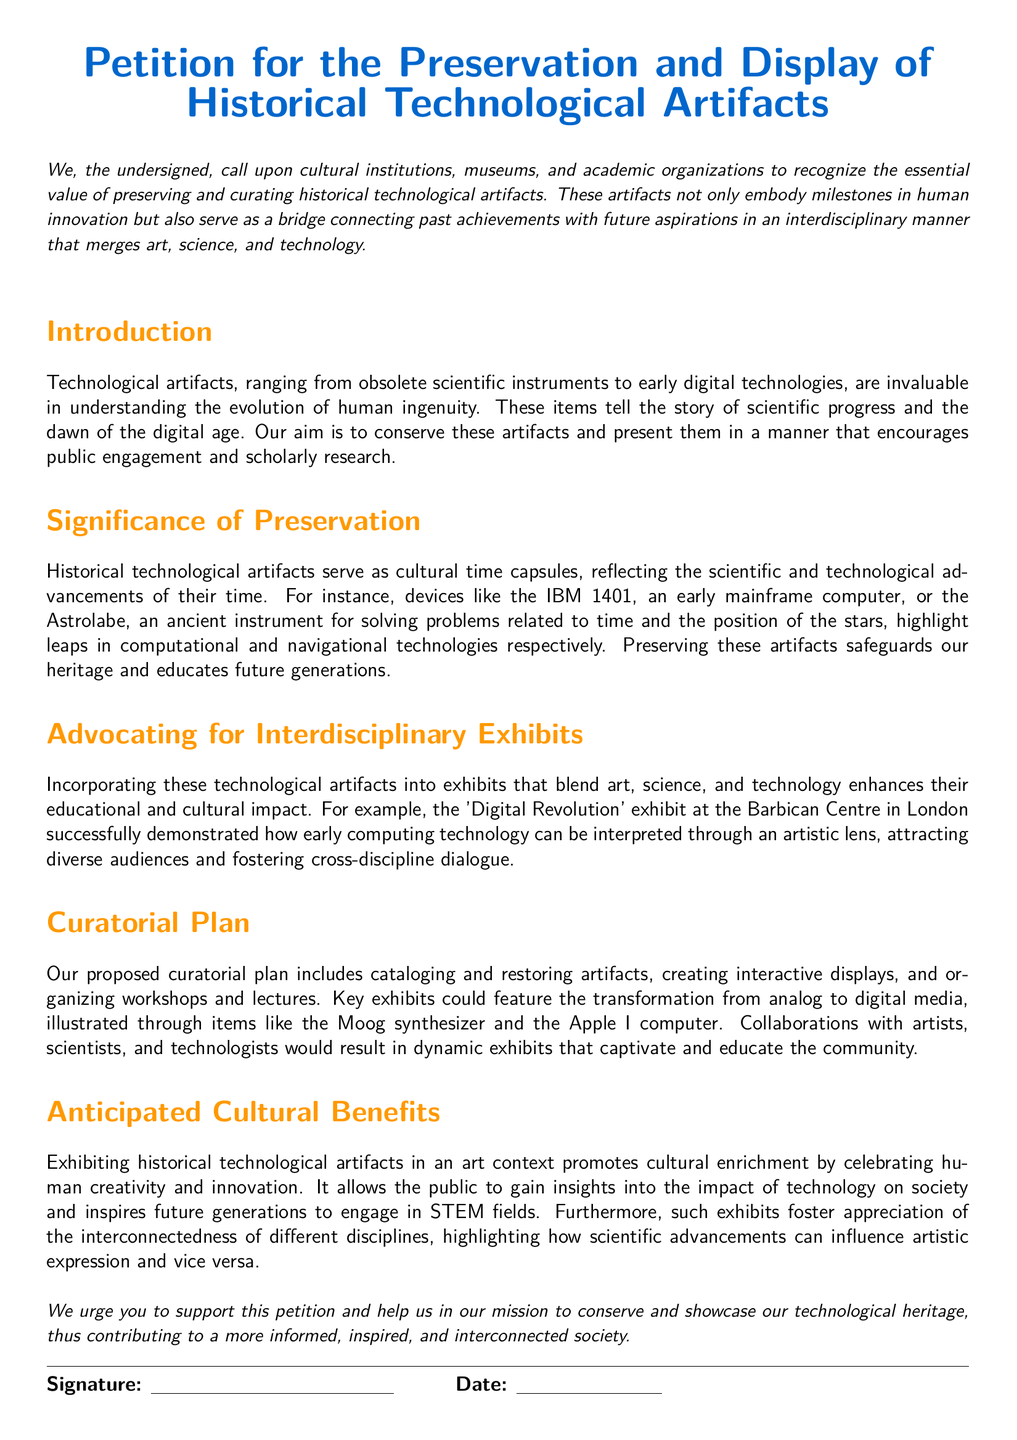What is the title of the petition? The title of the petition is clearly stated at the top of the document, specifically designed for recognition.
Answer: Petition for the Preservation and Display of Historical Technological Artifacts What type of artifacts does the petition advocate preserving? The petition specifies that it advocates for the preservation of technological artifacts, particularly those that are obsolete or early digital technologies.
Answer: Historical technological artifacts Who is the target audience for this petition? The petition calls upon cultural institutions, museums, and academic organizations to take action regarding the preservation of artifacts.
Answer: Cultural institutions, museums, and academic organizations What is one example of an artifact mentioned in the document? The document provides specific examples of artifacts, including a notable early computing device.
Answer: IBM 1401 What does the petition emphasize about the relationship between technology and art? The petition highlights that exhibits which combine art and technology can enhance educational and cultural impact, suggesting a synergy between the two fields.
Answer: Interdisciplinary exhibits In which city was a successful exhibit mentioned in the petition held? The petition references a specific location of a successful exhibit that was integrated with art and technology.
Answer: London What is one anticipated benefit of the proposed exhibits? The document outlines the cultural enrichment as a benefit from exhibiting historical artifacts in an art context, focusing on the societal impact.
Answer: Cultural enrichment What is one proposed activity in the curatorial plan? The curatorial plan includes various activities designed to engage the public and present the artifacts effectively.
Answer: Organizing workshops and lectures 